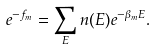<formula> <loc_0><loc_0><loc_500><loc_500>e ^ { - f _ { m } } = \sum _ { E } n ( E ) e ^ { - \beta _ { m } E } .</formula> 